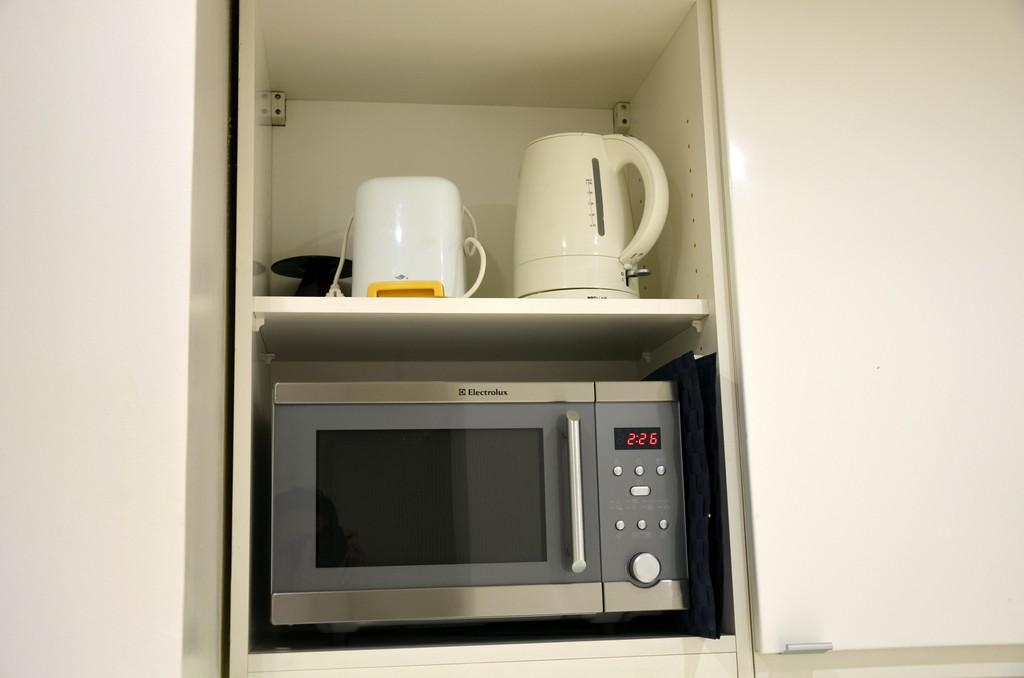<image>
Share a concise interpretation of the image provided. An Electrolux microwave is in a cabinet and the time is 2:26. 